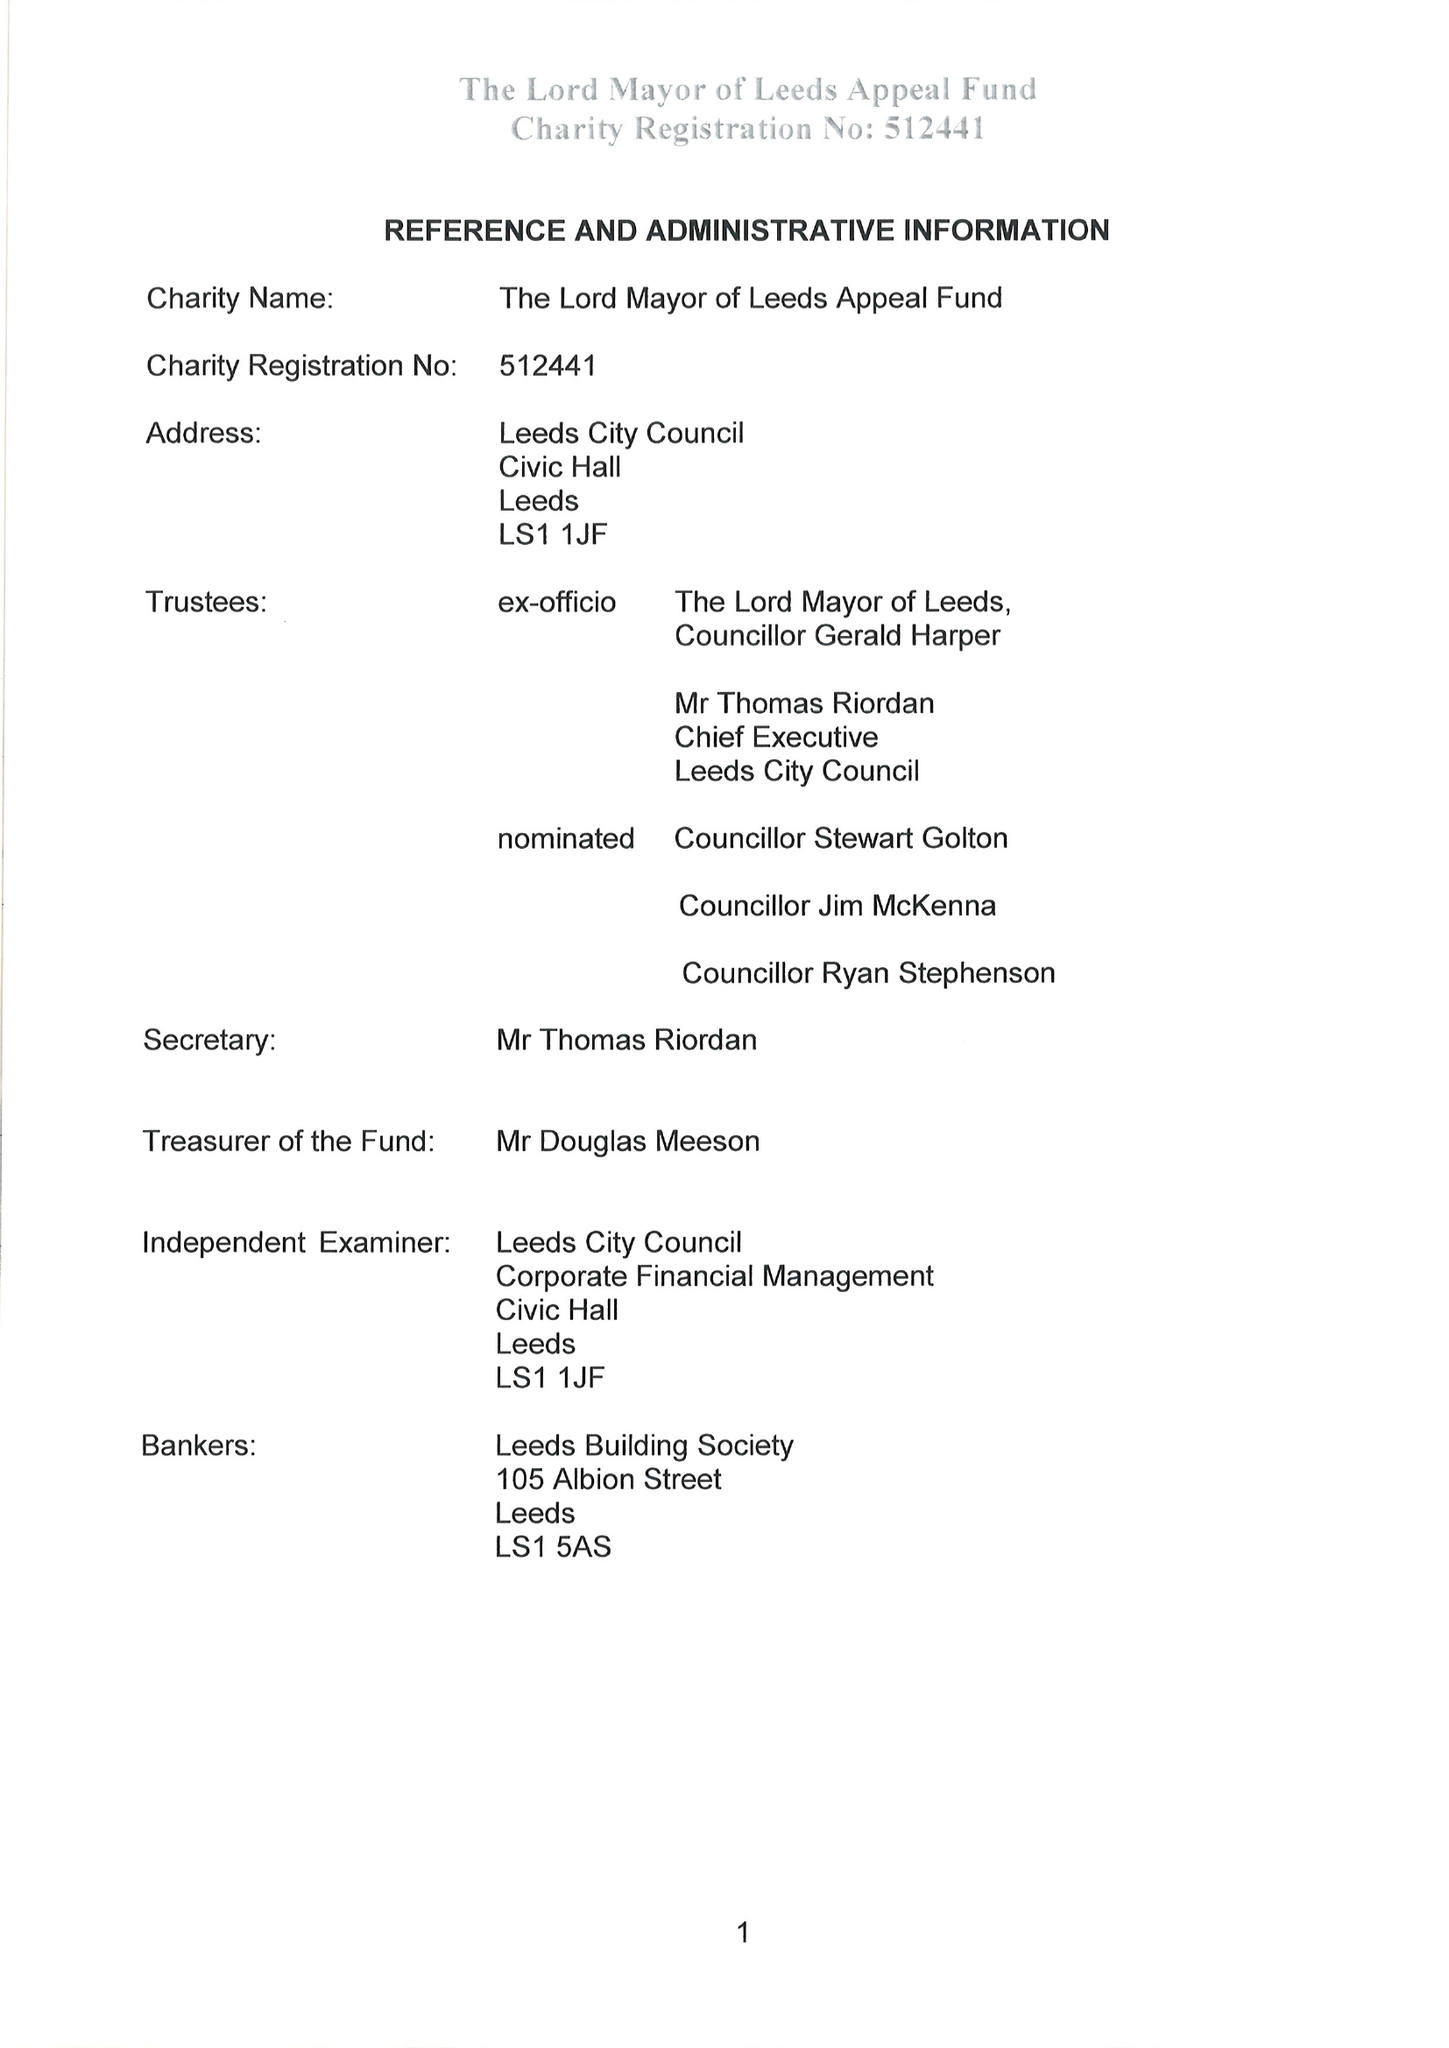What is the value for the address__post_town?
Answer the question using a single word or phrase. LEEDS 